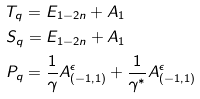Convert formula to latex. <formula><loc_0><loc_0><loc_500><loc_500>& T _ { q } = E _ { 1 - 2 n } + A _ { 1 } \\ & S _ { q } = E _ { 1 - 2 n } + A _ { 1 } \\ & P _ { q } = \frac { 1 } { \gamma } A _ { ( - 1 , 1 ) } ^ { \epsilon } + \frac { 1 } { \gamma ^ { \ast } } A _ { ( - 1 , 1 ) } ^ { \epsilon }</formula> 